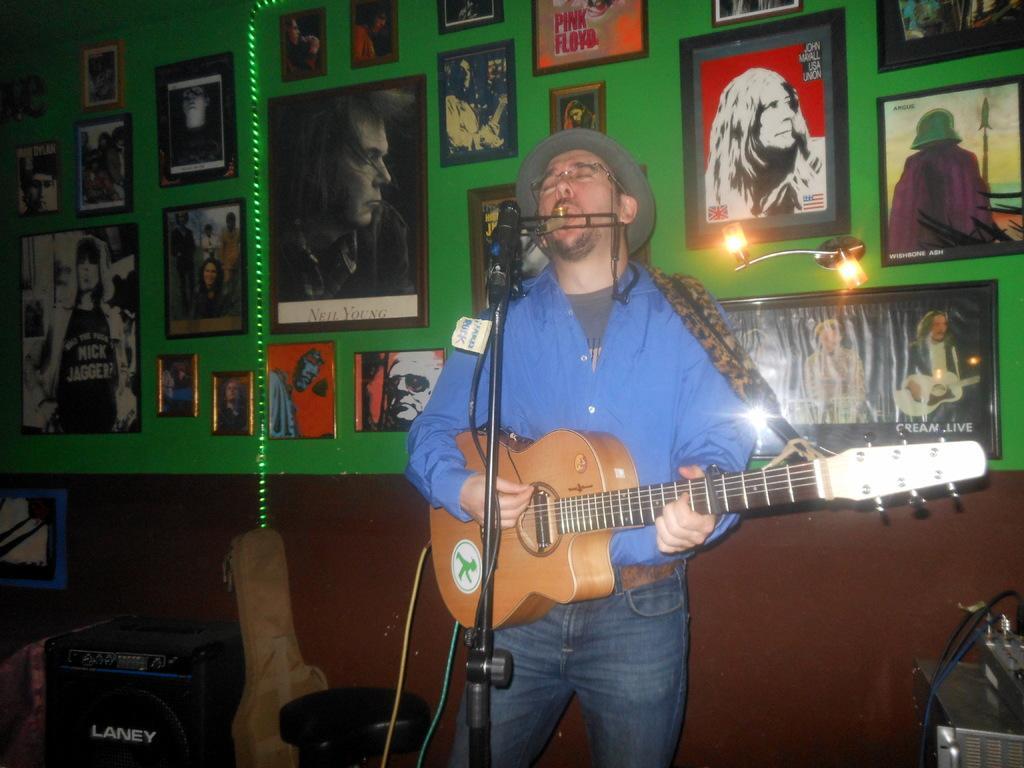In one or two sentences, can you explain what this image depicts? This person standing playing guitar and singing. There is a microphone with stand. On the background we can see wall,frames,posters. We can see chairs,speakers on the floor. 